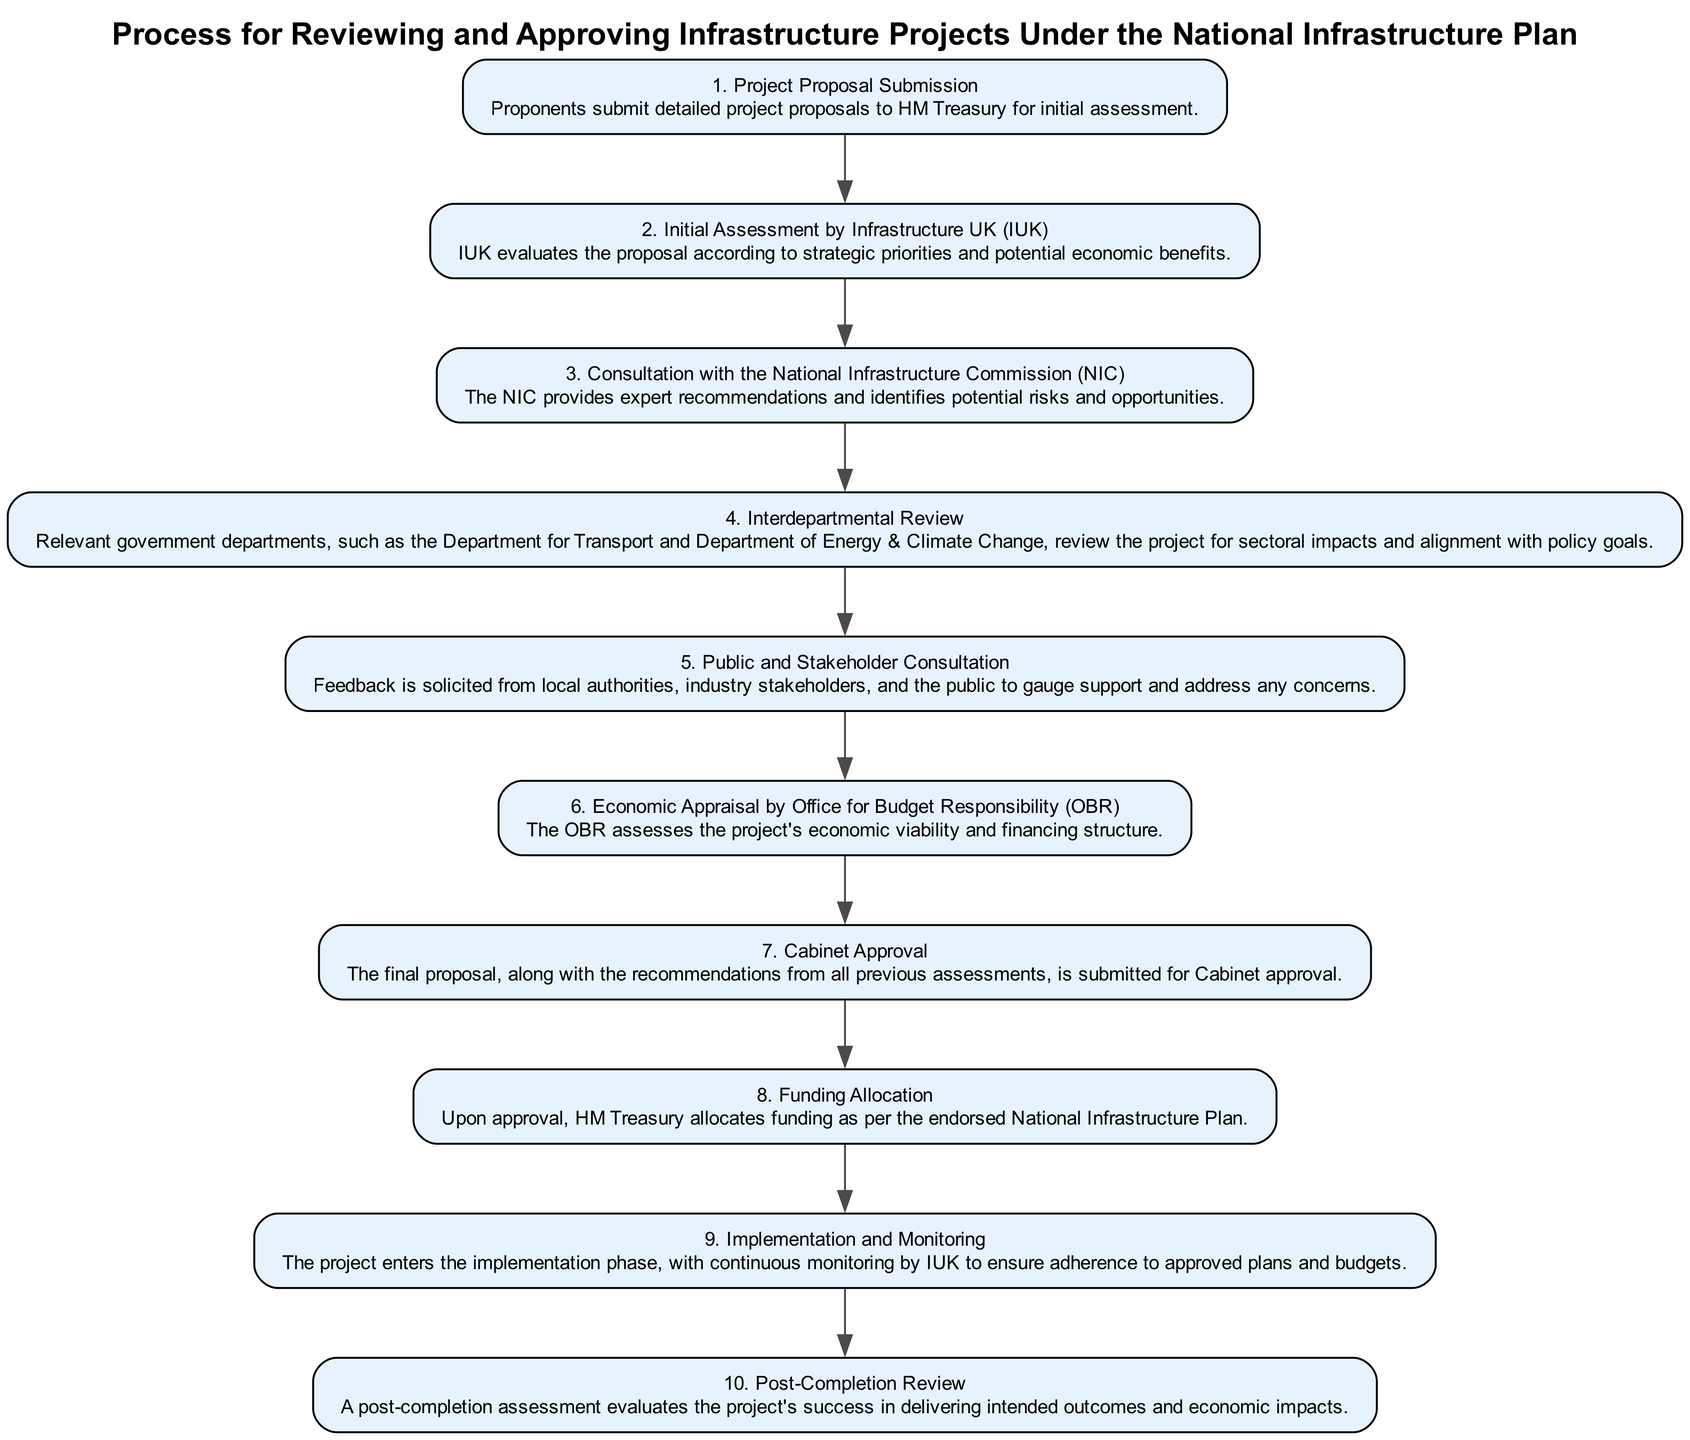What is the first step in the process? The first step is "Project Proposal Submission." It is labeled as Step 1 in the diagram, indicating it is the starting point of the entire process.
Answer: Project Proposal Submission How many total steps are there in the process? There are ten steps in total as indicated by the numbering from Step 1 to Step 10 within the diagram.
Answer: 10 What step comes immediately after the "Public and Stakeholder Consultation"? The step immediately after "Public and Stakeholder Consultation" is "Economic Appraisal by Office for Budget Responsibility (OBR)," which is labeled as Step 6.
Answer: Economic Appraisal by Office for Budget Responsibility Which department is involved in the "Interdepartmental Review"? The "Interdepartmental Review" involves relevant government departments, including the Department for Transport and the Department of Energy & Climate Change. Both departments are mentioned in the description of Step 4.
Answer: Department for Transport and Department of Energy & Climate Change What is the final step in the process? The final step in the process is "Post-Completion Review," denoted as Step 10, which evaluates the project's success after completion.
Answer: Post-Completion Review What does "HM Treasury" do after Cabinet approval? After Cabinet approval, "HM Treasury" allocates funding as per the endorsed National Infrastructure Plan, which is the action outlined in Step 8.
Answer: Allocates funding Explain the role of the National Infrastructure Commission (NIC) in this process. The NIC's role is to provide expert recommendations and identify potential risks and opportunities during the "Consultation with the National Infrastructure Commission" which is Step 3 in the process.
Answer: Provide expert recommendations and identify potential risks and opportunities What is monitored during the "Implementation and Monitoring" phase? During the "Implementation and Monitoring" phase, continuous monitoring of the project is conducted by IUK to ensure adherence to approved plans and budgets, as stated in Step 9.
Answer: Continuous monitoring by IUK Which step directly follows the "Economic Appraisal by Office for Budget Responsibility"? The step that follows "Economic Appraisal by Office for Budget Responsibility" is "Cabinet Approval," which is Step 7, indicating the necessary approval needed after financial assessment.
Answer: Cabinet Approval What is the purpose of the "Public and Stakeholder Consultation"? The purpose of the "Public and Stakeholder Consultation" is to solicit feedback from various stakeholders including local authorities and industry stakeholders to gauge support and address any concerns, which is detailed in Step 5.
Answer: Solicit feedback from stakeholders 